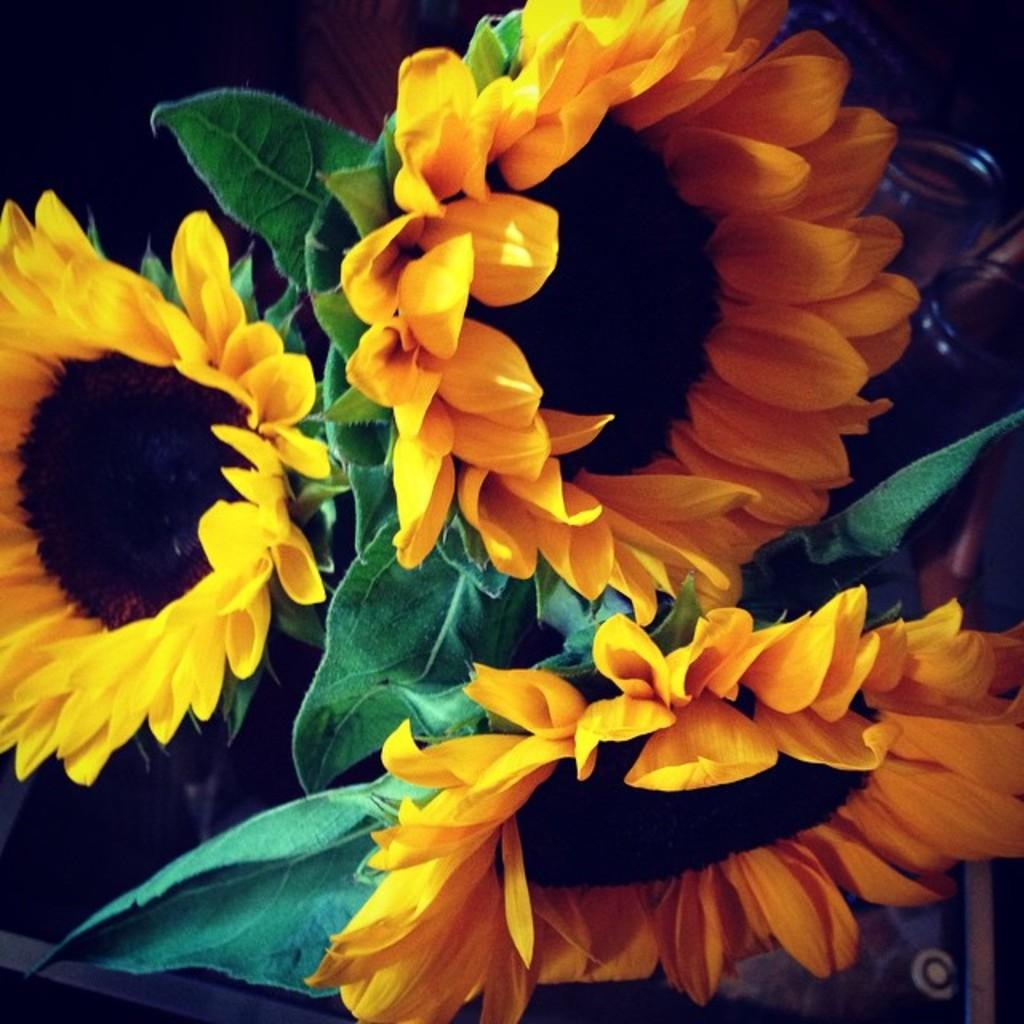What colors are the flowers in the image? The flowers in the image are yellow and black. What other elements can be seen in the image besides the flowers? There are green leaves in the image. What is the color of the background in the image? The background of the image is black. What type of ornament is hanging from the yellow and black flowers in the image? There is no ornament hanging from the yellow and black flowers in the image. How many eggs can be seen in the image? There are no eggs present in the image. 